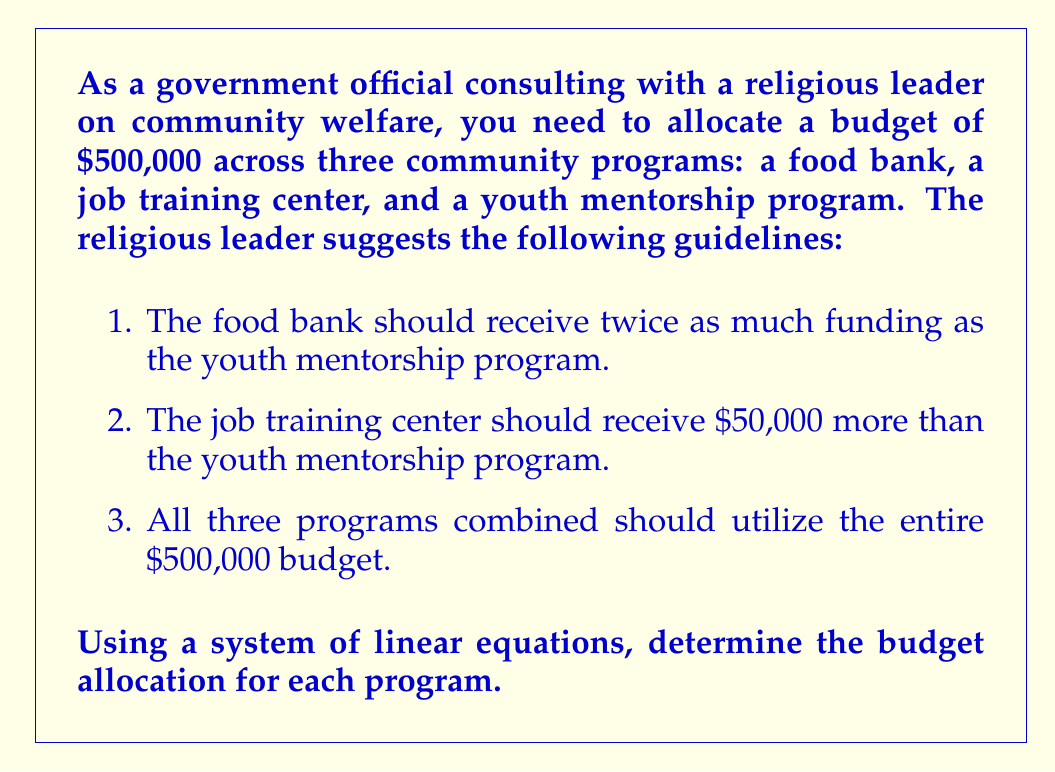Provide a solution to this math problem. Let's approach this problem step-by-step using a system of linear equations:

1. Define variables:
   Let $x$ = funding for the youth mentorship program
   Let $y$ = funding for the food bank
   Let $z$ = funding for the job training center

2. Translate the given information into equations:
   
   Equation 1: $y = 2x$ (food bank receives twice as much as youth mentorship)
   Equation 2: $z = x + 50000$ (job training receives $50,000 more than youth mentorship)
   Equation 3: $x + y + z = 500000$ (total budget constraint)

3. Substitute equations 1 and 2 into equation 3:

   $x + 2x + (x + 50000) = 500000$

4. Simplify:

   $4x + 50000 = 500000$

5. Solve for $x$:

   $4x = 450000$
   $x = 112500$

6. Now that we know $x$, we can solve for $y$ and $z$:

   $y = 2x = 2(112500) = 225000$
   $z = x + 50000 = 112500 + 50000 = 162500$

7. Verify the solution:
   
   $x + y + z = 112500 + 225000 + 162500 = 500000$

Therefore, the budget allocations are:
- Youth mentorship program: $112,500
- Food bank: $225,000
- Job training center: $162,500
Answer: Youth mentorship program: $112,500
Food bank: $225,000
Job training center: $162,500 